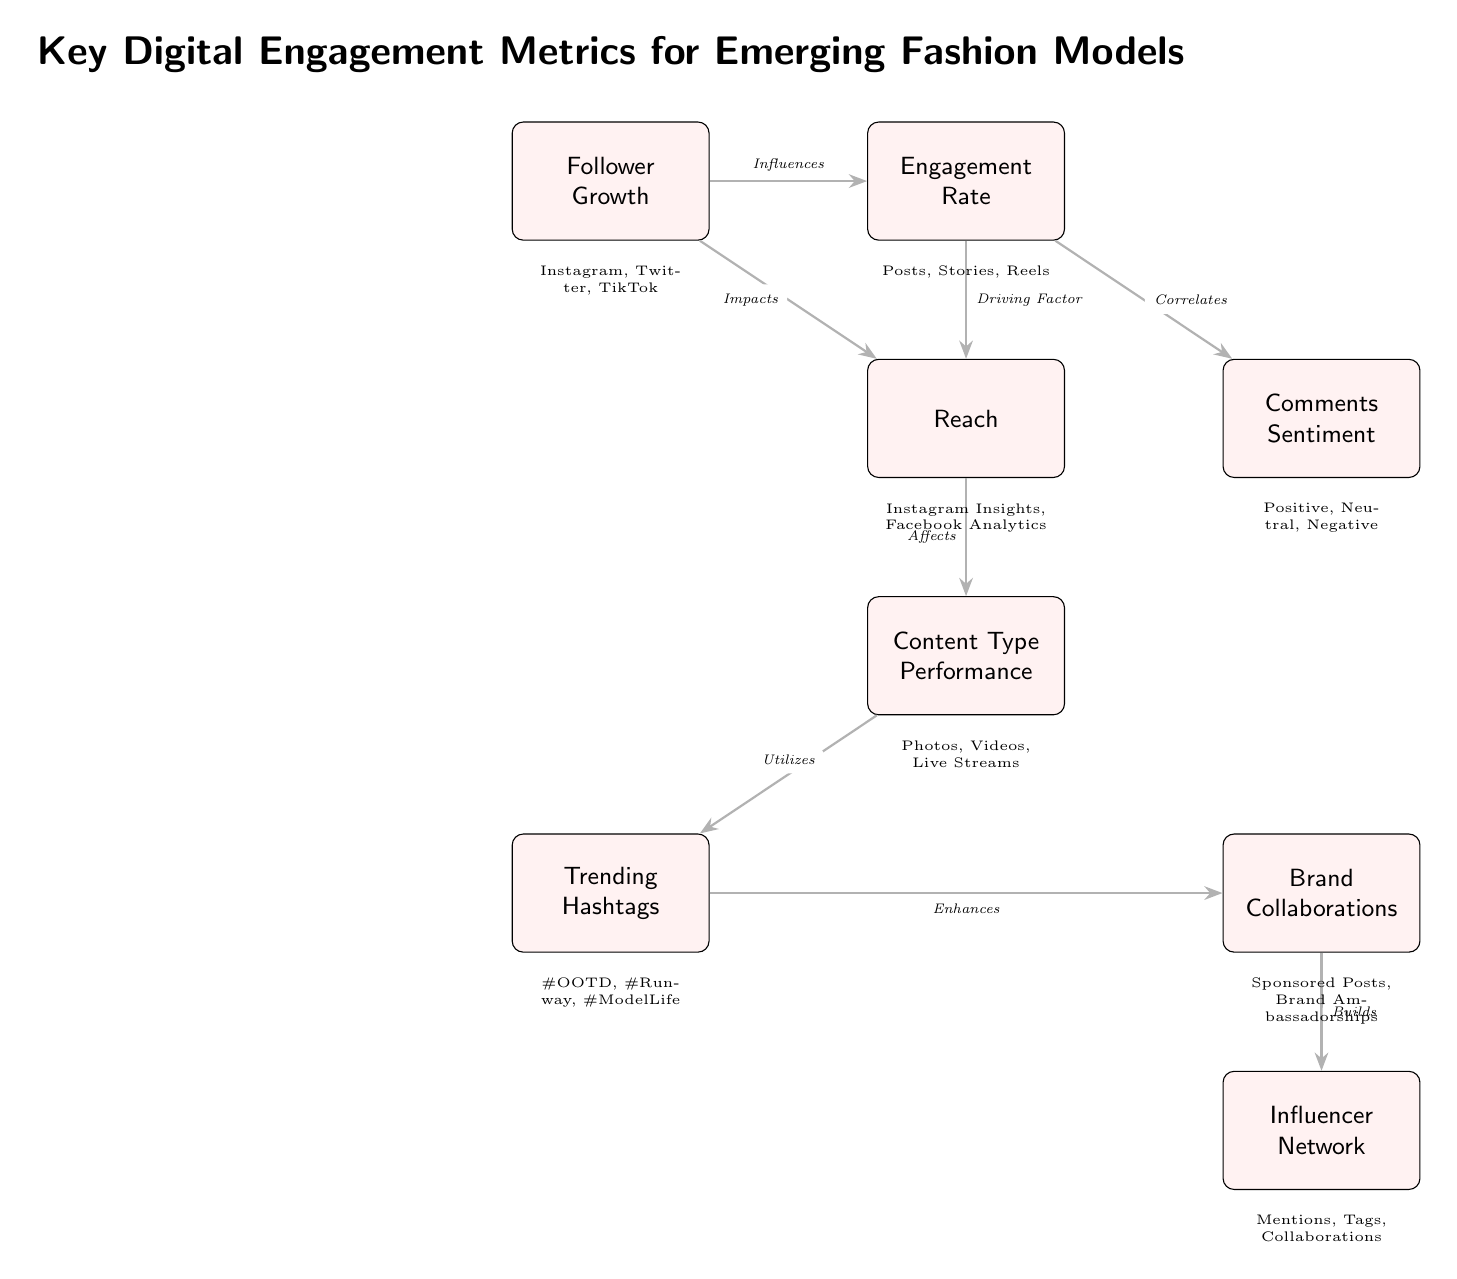What is the primary factor that influences follower growth? The diagram shows an arrow from the "Follower Growth" node to the "Engagement Rate" node, labeled as "Influences." This indicates that engagement rate is the primary factor that influences follower growth.
Answer: Engagement Rate How many key metrics are represented in the diagram? The diagram contains eight distinct metrics represented by nodes, which are labeled in pink. Counting these nodes confirms that there are eight metrics.
Answer: Eight What does reach impact in the diagram? According to the diagram, the "Reach" node has an arrow pointing towards "Content Type Performance," labeled "Affects." This indicates that reach impacts content type performance.
Answer: Content Type Performance Which metric correlates with comments sentiment? As illustrated in the diagram, there is an arrow from "Engagement Rate" to "Comments Sentiment," labeled "Correlates." This means that comments sentiment correlates with engagement rate.
Answer: Engagement Rate What are the two metrics categorized under content performance? The diagram lists "Content Type Performance" and "Trending Hashtags" as metrics categorized under content performance. They are interconnected through their relation to content strategy.
Answer: Content Type Performance and Trending Hashtags What builds the influencer network according to the diagram? The last connection in the diagram shows an arrow going from "Brand Collaborations" to "Influencer Network," labeled "Builds." This indicates that brand collaborations build the influencer network.
Answer: Brand Collaborations How does engagement rate relate to reach? There is a direct connection between "Engagement Rate" and "Reach" in the diagram with the label "Driving Factor." This signifies that engagement rate is a driving factor for reach.
Answer: Driving Factor What type of performance does reach affect? The diagram indicates that "Reach" affects "Content Type Performance," showing a direct relationship where reach influences the type of content that performs well.
Answer: Content Type Performance 